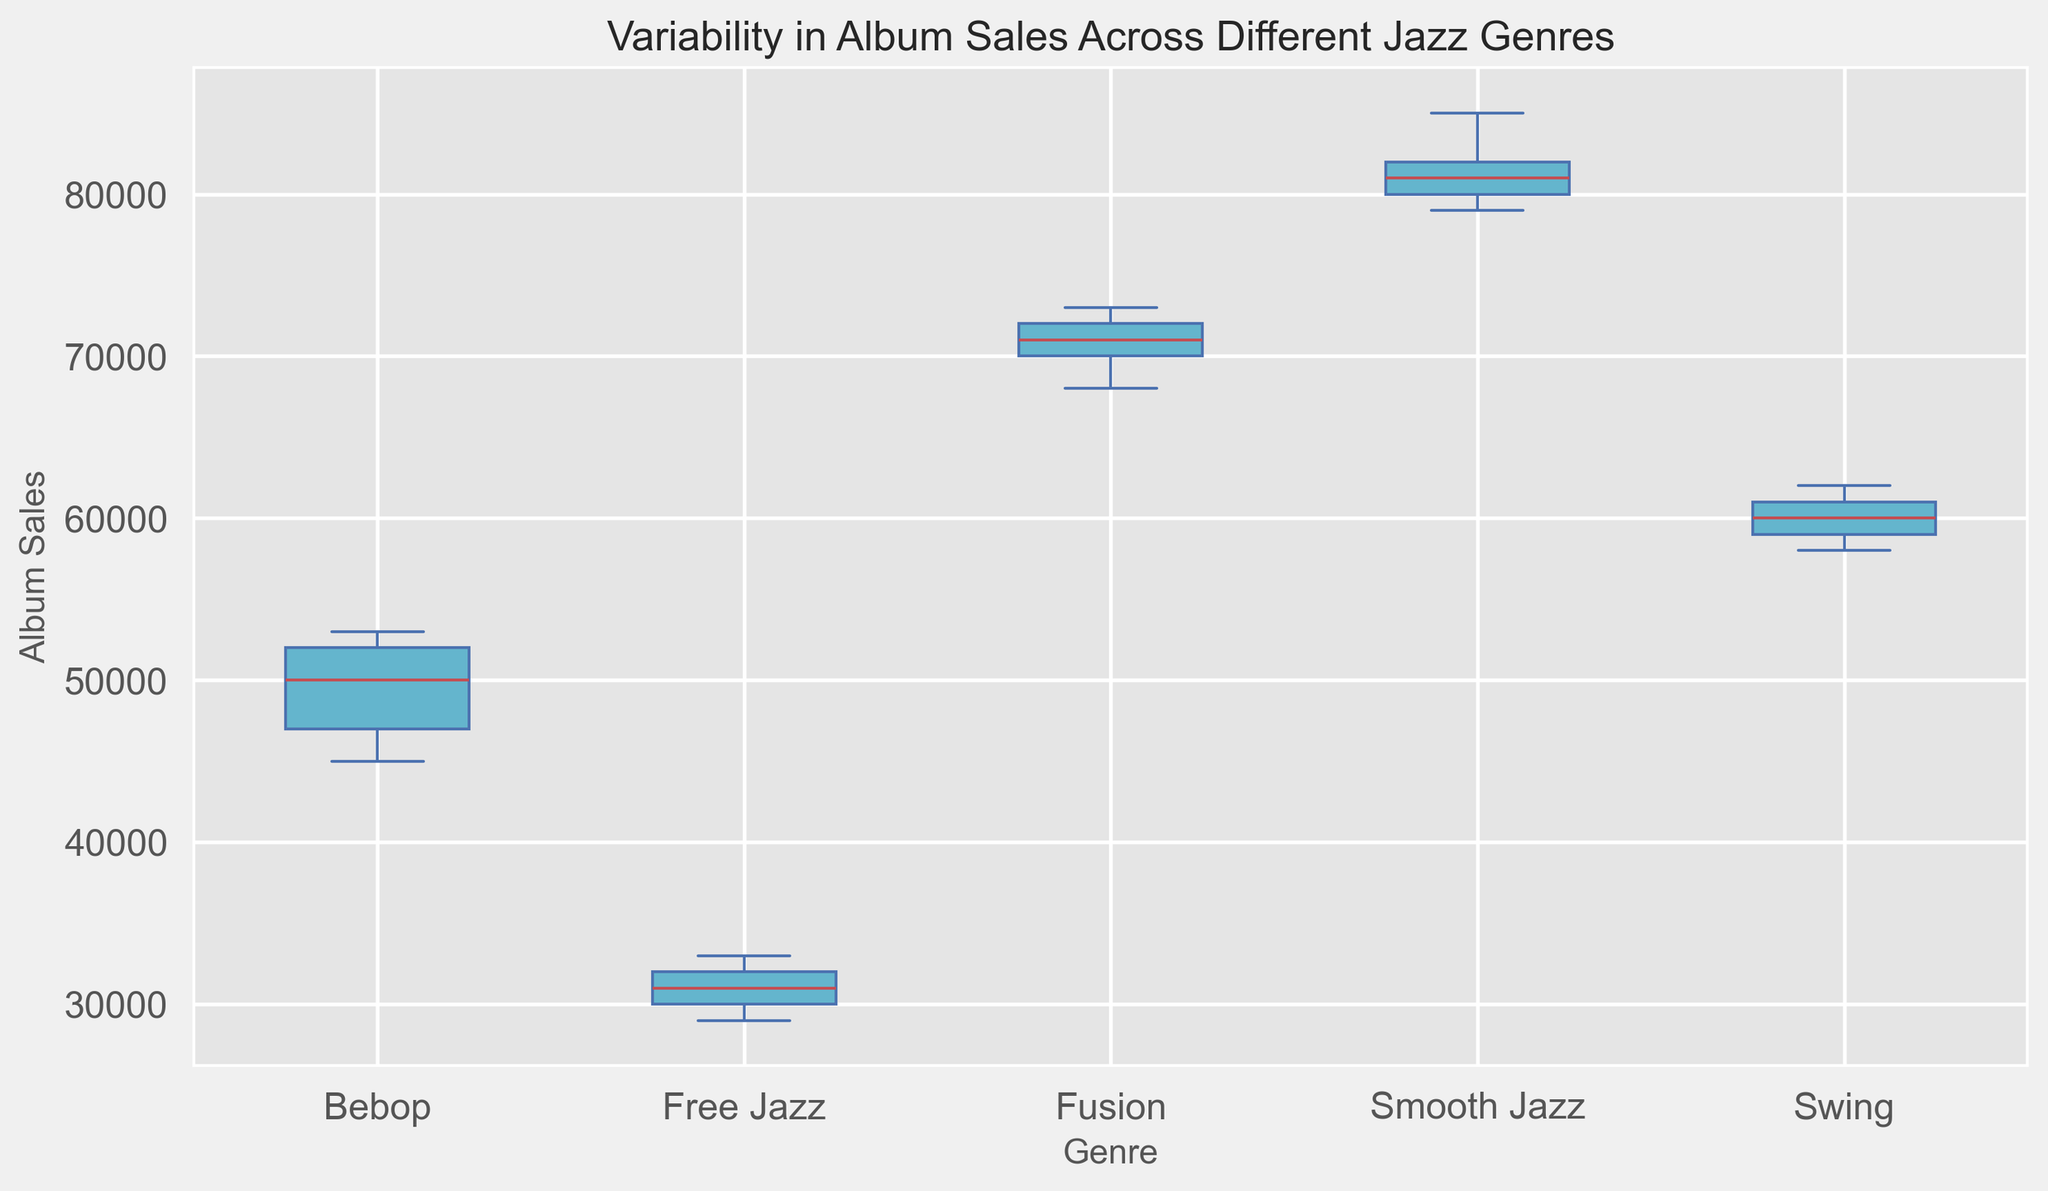What is the median album sales for Bebop? Find the middle value of the sorted album sales data for Bebop: 45000, 47000, 50000, 52000, 53000. The median is the middle number, which is 50000.
Answer: 50000 Which jazz genre has the highest median album sales? Identify the genre with the highest central value in the box plot. Smooth Jazz has the highest median, shown at 81000.
Answer: Smooth Jazz Which genre has the smallest interquartile range (IQR) of album sales? The IQR is the difference between the first quartile (Q1) and the third quartile (Q3). Swing has the smallest IQR, as the box (Q3-Q1) appears the smallest visually.
Answer: Swing How does the median album sales of Fusion compare to that of Free Jazz? Find the median values of both genres: Fusion's median is 71000, and Free Jazz's median is 31000. The median for Fusion is higher.
Answer: Fusion's median is higher What is the range of album sales in Smooth Jazz? The range is the difference between the maximum and minimum values. For Smooth Jazz, the maximum is 85000 and the minimum is 79000. So the range is 85000 - 79000 = 6000.
Answer: 6000 Which genre has the most variability in album sales? Variability can be seen through the length of the whiskers in the box plot. Free Jazz has the widest spread of sales values, indicating the most variability.
Answer: Free Jazz Order the genres from highest to lowest median album sales. Identify and sort the genres based on their median values: Smooth Jazz (81000), Fusion (71000), Swing (60000), Bebop (50000), Free Jazz (31000).
Answer: Smooth Jazz, Fusion, Swing, Bebop, Free Jazz Which genre has the least outliers in album sales? Outliers are shown as individual points outside the whiskers. Bebop, Swing, Fusion, and Smooth Jazz have no outliers, whereas Free Jazz has none too. So, all have the least outliers.
Answer: Bebop, Swing, Fusion, Smooth Jazz, Free Jazz Is the interquartile range (IQR) of Bebop greater than that of Swing? Calculate the IQR visually: Bebop has a slightly larger IQR than Swing, as its box appears marginally larger.
Answer: Yes 